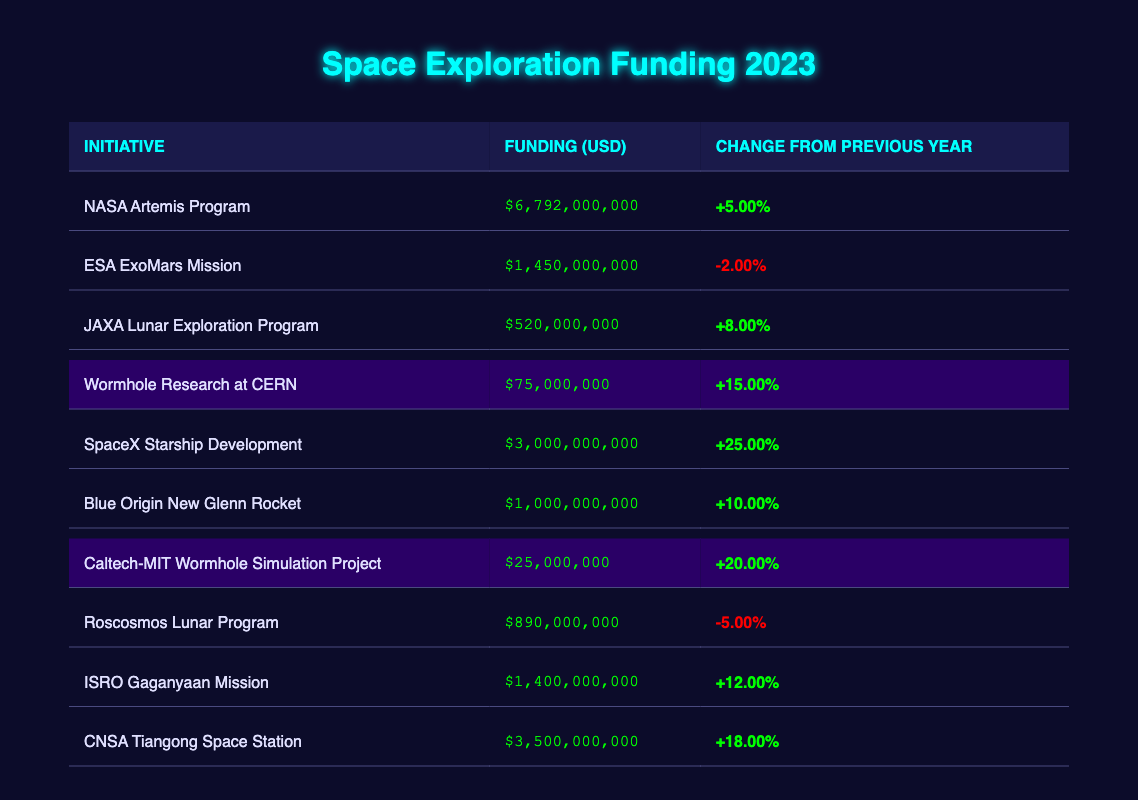What is the funding amount for the NASA Artemis Program? The funding amount for the NASA Artemis Program can be found in the corresponding row of the table, which shows $6,792,000,000.
Answer: 6,792,000,000 Which initiative received the highest funding in 2023? By reviewing the funding amounts listed in the table, the NASA Artemis Program has the highest funding at $6,792,000,000.
Answer: NASA Artemis Program What is the percentage change in funding for the Wormhole Research at CERN from the previous year? The change from the previous year for Wormhole Research at CERN is indicated in the table as +15.00%.
Answer: +15.00% What is the total funding for all wormhole-related initiatives? To find the total funding for wormhole-related initiatives, we add the funding for Wormhole Research at CERN ($75,000,000) and Caltech-MIT Wormhole Simulation Project ($25,000,000), which totals $100,000,000.
Answer: 100,000,000 Is the funding for ESA ExoMars Mission higher than that for the Blue Origin New Glenn Rocket? In the table, the funding for ESA ExoMars Mission is $1,450,000,000, while the funding for Blue Origin New Glenn Rocket is $1,000,000,000. Since $1,450,000,000 is greater than $1,000,000,000, the statement is true.
Answer: Yes What is the average funding amount for all initiatives listed in the table? The total funding can be calculated by summing each initiative's amount: $6,792,000,000 + $1,450,000,000 + $520,000,000 + $75,000,000 + $3,000,000,000 + $1,000,000,000 + $25,000,000 + $890,000,000 + $1,400,000,000 + $3,500,000,000 = $18,487,000,000. There are 10 initiatives, so the average funding is $18,487,000,000 / 10 = $1,848,700,000.
Answer: 1,848,700,000 Did the JAXA Lunar Exploration Program see an increase in funding compared to the previous year? The table indicates that JAXA Lunar Exploration Program had a funding change of +8.00%. Since it is a positive change, it confirms that there was an increase in funding.
Answer: Yes Which initiatives have decreased their funding compared to the previous year? The table shows that the ESA ExoMars Mission had a decrease of -2.00% and the Roscosmos Lunar Program had a decrease of -5.00%, indicating both initiatives received lower funding in 2023 compared to the previous year.
Answer: ESA ExoMars Mission, Roscosmos Lunar Program 